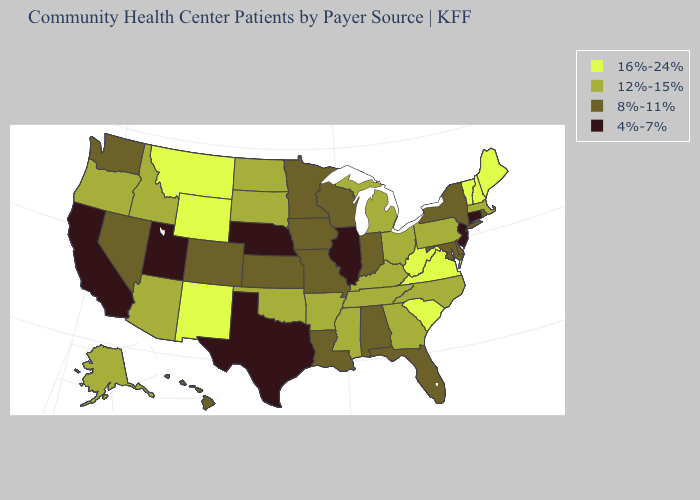Among the states that border South Carolina , which have the highest value?
Give a very brief answer. Georgia, North Carolina. Name the states that have a value in the range 12%-15%?
Write a very short answer. Alaska, Arizona, Arkansas, Georgia, Idaho, Kentucky, Massachusetts, Michigan, Mississippi, North Carolina, North Dakota, Ohio, Oklahoma, Oregon, Pennsylvania, South Dakota, Tennessee. Among the states that border New York , which have the lowest value?
Quick response, please. Connecticut, New Jersey. Does the first symbol in the legend represent the smallest category?
Short answer required. No. Does Texas have the lowest value in the South?
Be succinct. Yes. Does the first symbol in the legend represent the smallest category?
Be succinct. No. Does New Mexico have the highest value in the USA?
Give a very brief answer. Yes. Does Illinois have a lower value than Maine?
Short answer required. Yes. Among the states that border Texas , which have the highest value?
Write a very short answer. New Mexico. What is the value of Illinois?
Keep it brief. 4%-7%. What is the value of Pennsylvania?
Concise answer only. 12%-15%. Among the states that border Connecticut , does Massachusetts have the lowest value?
Quick response, please. No. Name the states that have a value in the range 16%-24%?
Write a very short answer. Maine, Montana, New Hampshire, New Mexico, South Carolina, Vermont, Virginia, West Virginia, Wyoming. What is the value of Maine?
Concise answer only. 16%-24%. 